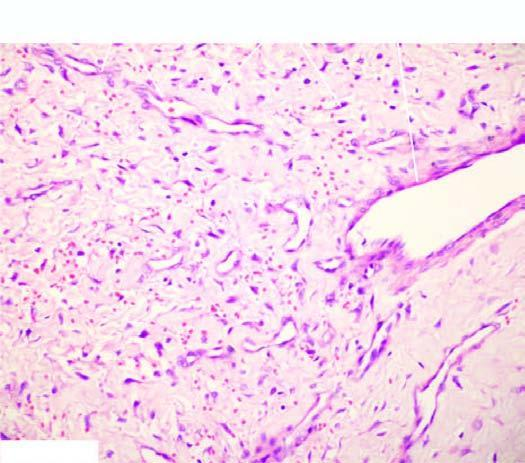re the blood vessels variable-sized?
Answer the question using a single word or phrase. Yes 